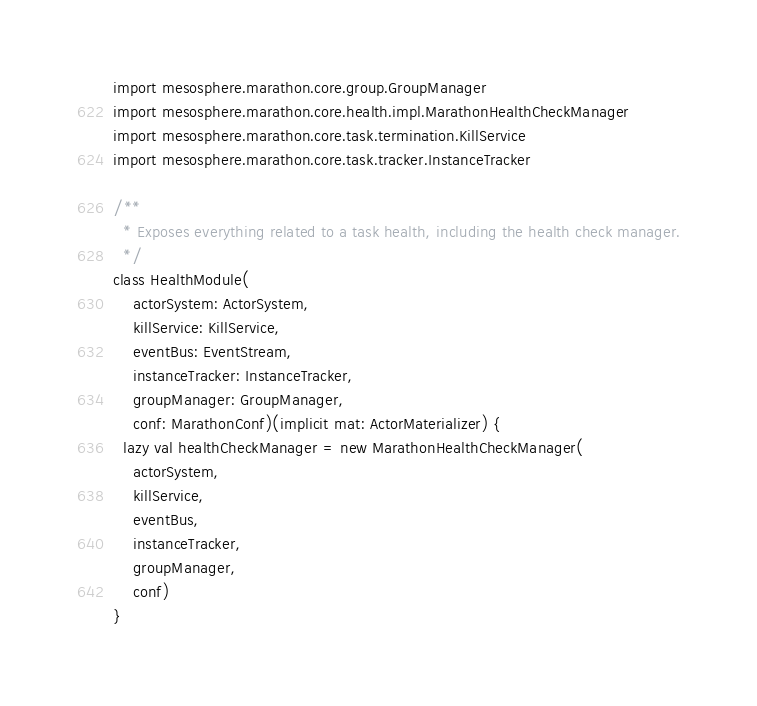Convert code to text. <code><loc_0><loc_0><loc_500><loc_500><_Scala_>import mesosphere.marathon.core.group.GroupManager
import mesosphere.marathon.core.health.impl.MarathonHealthCheckManager
import mesosphere.marathon.core.task.termination.KillService
import mesosphere.marathon.core.task.tracker.InstanceTracker

/**
  * Exposes everything related to a task health, including the health check manager.
  */
class HealthModule(
    actorSystem: ActorSystem,
    killService: KillService,
    eventBus: EventStream,
    instanceTracker: InstanceTracker,
    groupManager: GroupManager,
    conf: MarathonConf)(implicit mat: ActorMaterializer) {
  lazy val healthCheckManager = new MarathonHealthCheckManager(
    actorSystem,
    killService,
    eventBus,
    instanceTracker,
    groupManager,
    conf)
}
</code> 